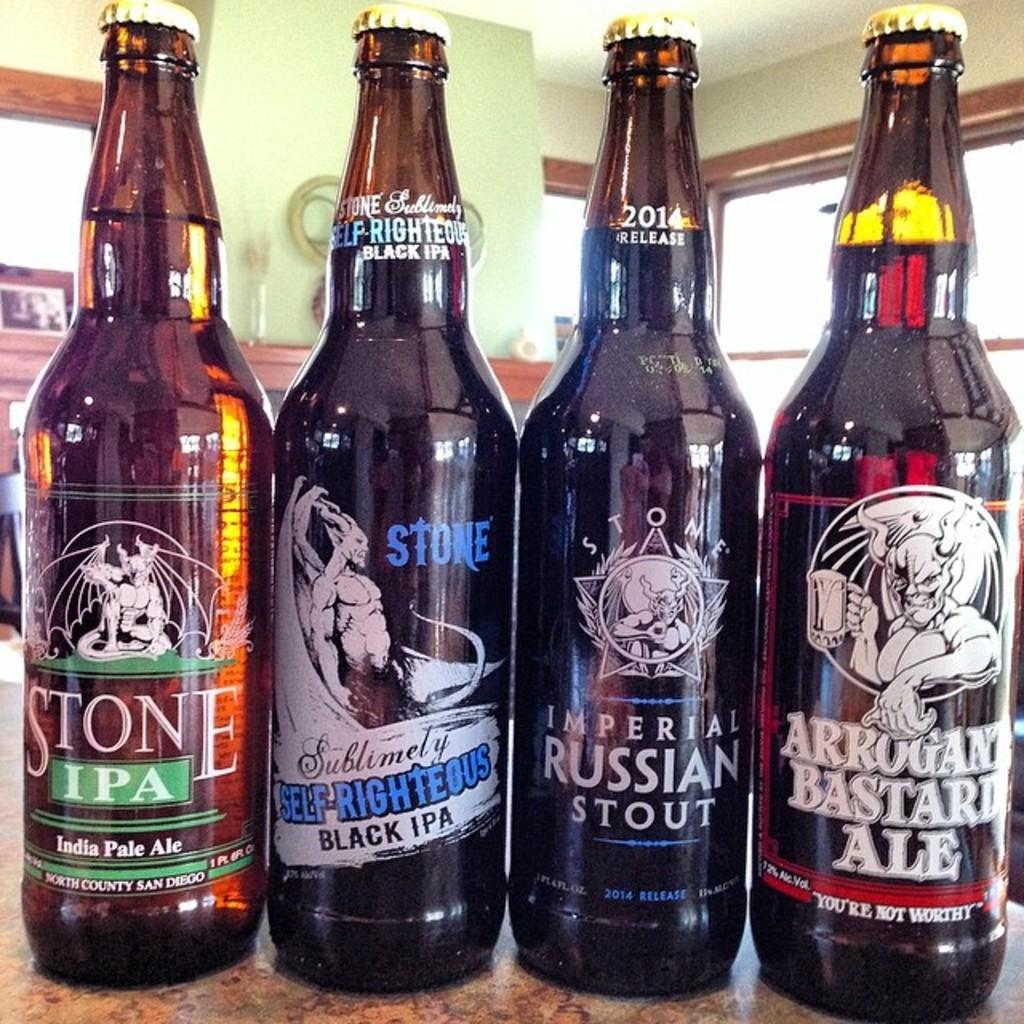<image>
Create a compact narrative representing the image presented. IPA, stout, and an ale with different demon pictures on them. 